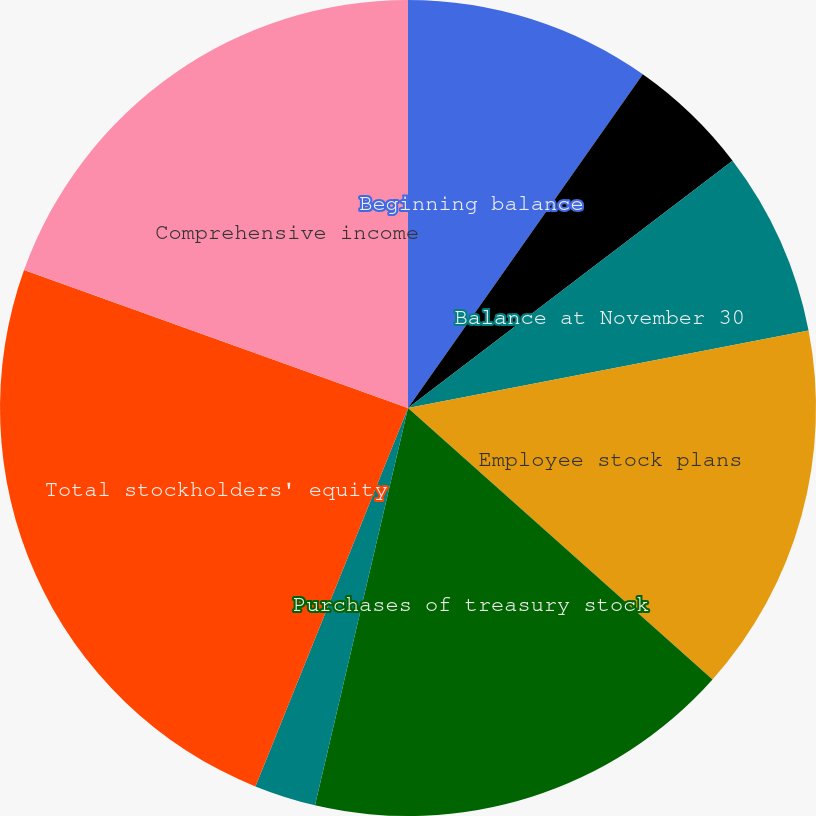Convert chart to OTSL. <chart><loc_0><loc_0><loc_500><loc_500><pie_chart><fcel>Beginning balance<fcel>Deferred compensation activity<fcel>Balance at November 30<fcel>Employee stock plans<fcel>Purchases of treasury stock<fcel>Unrealized gains arising<fcel>Change to the Company's<fcel>Total stockholders' equity<fcel>Comprehensive income<nl><fcel>9.76%<fcel>4.88%<fcel>7.32%<fcel>14.63%<fcel>17.07%<fcel>0.0%<fcel>2.44%<fcel>24.39%<fcel>19.51%<nl></chart> 